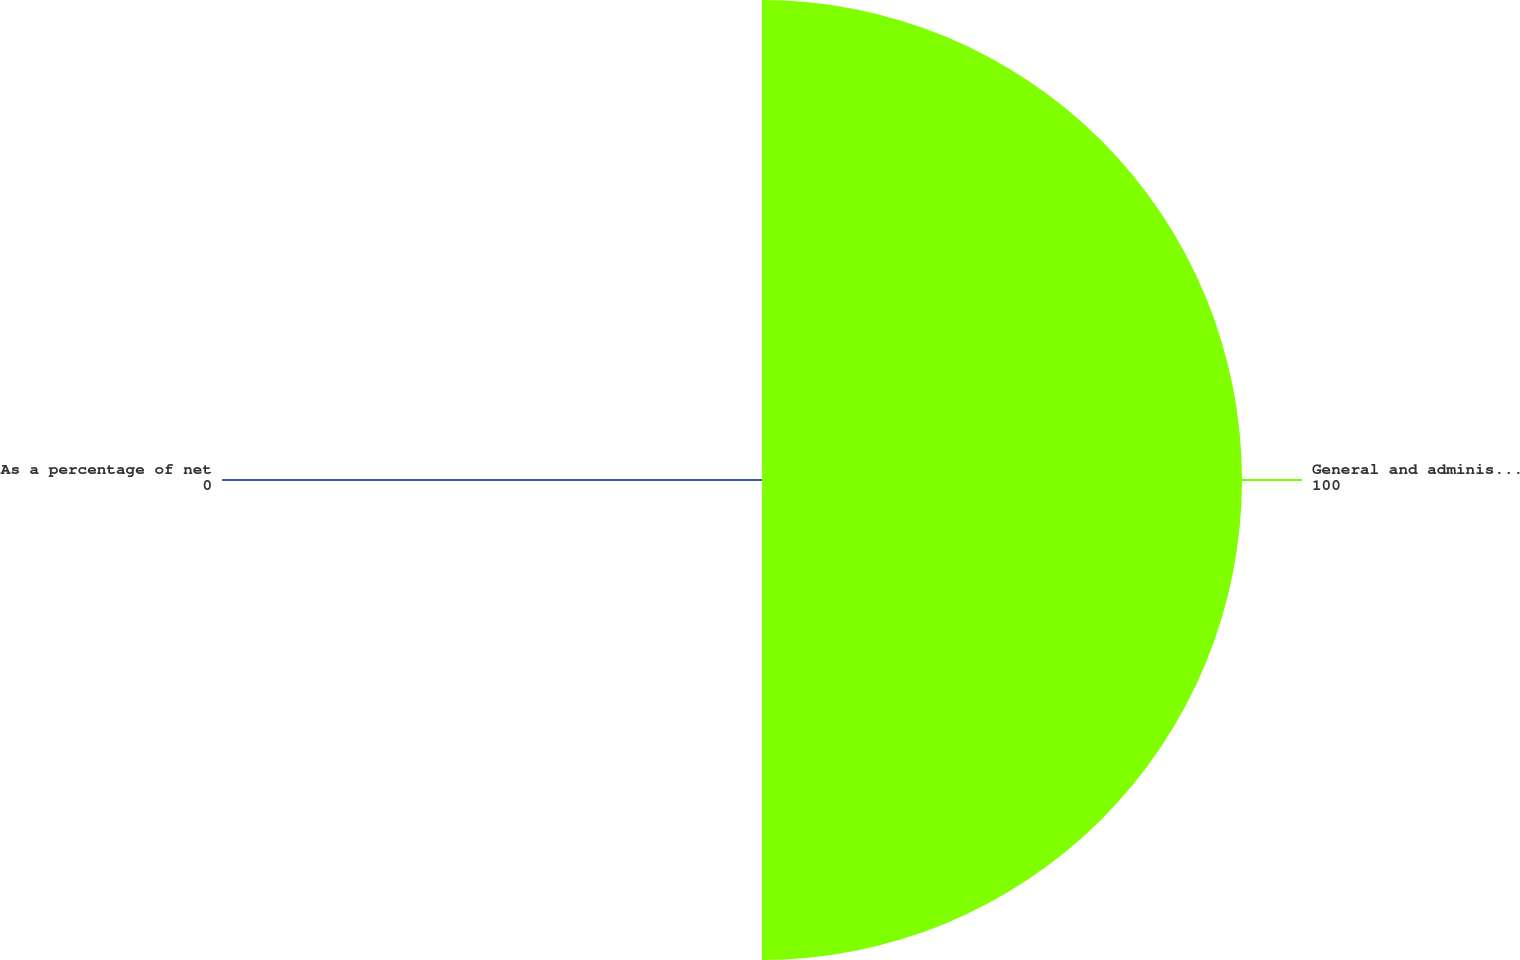Convert chart to OTSL. <chart><loc_0><loc_0><loc_500><loc_500><pie_chart><fcel>General and administrative<fcel>As a percentage of net<nl><fcel>100.0%<fcel>0.0%<nl></chart> 